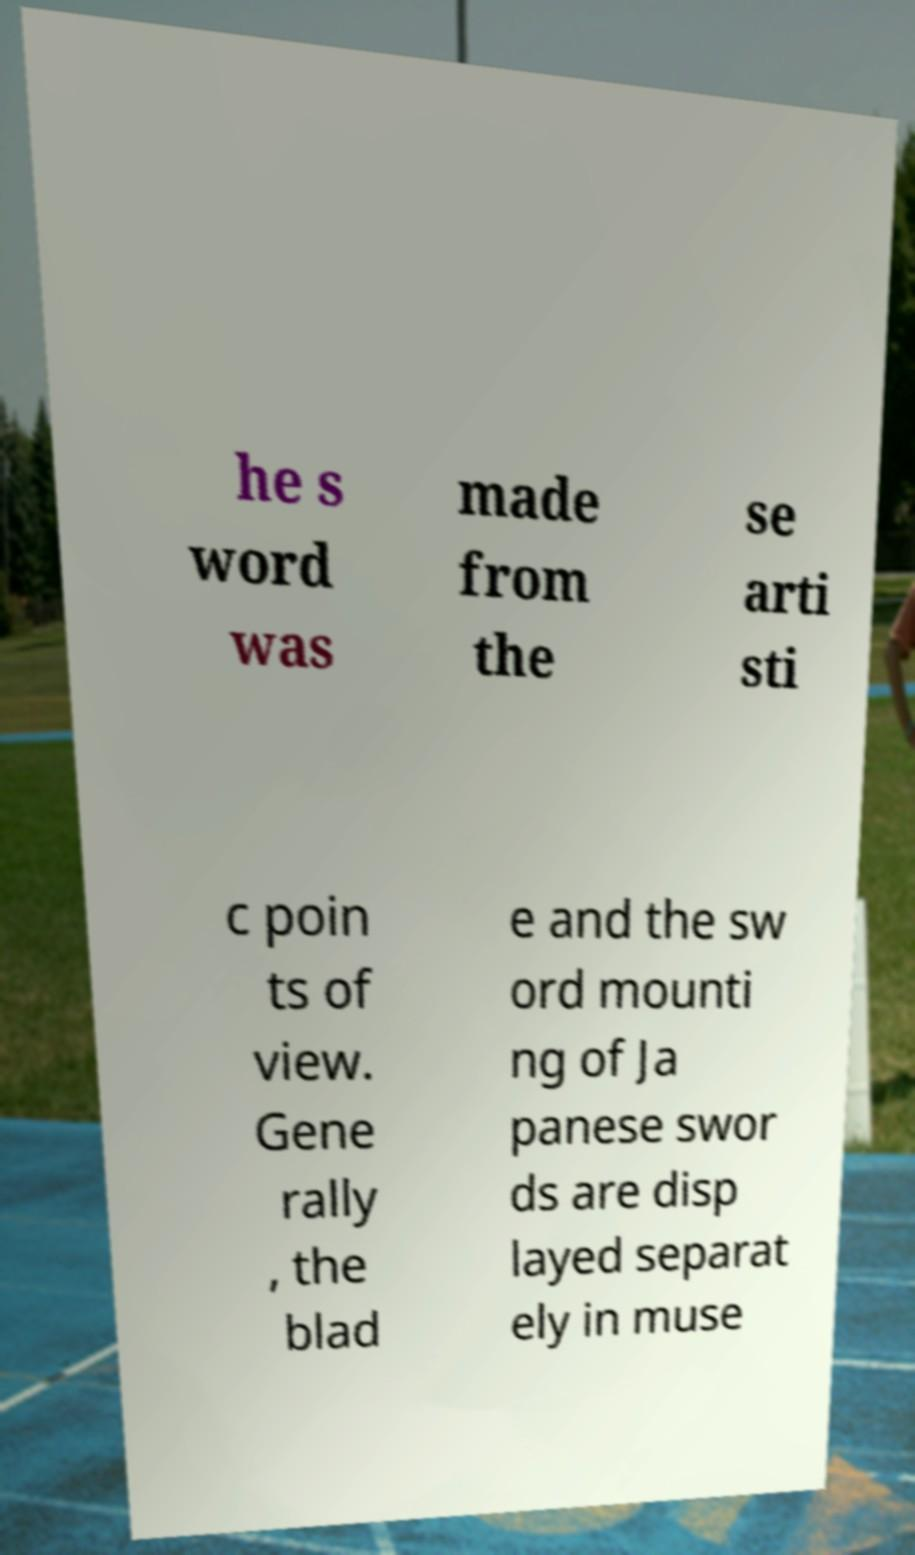Can you read and provide the text displayed in the image?This photo seems to have some interesting text. Can you extract and type it out for me? he s word was made from the se arti sti c poin ts of view. Gene rally , the blad e and the sw ord mounti ng of Ja panese swor ds are disp layed separat ely in muse 